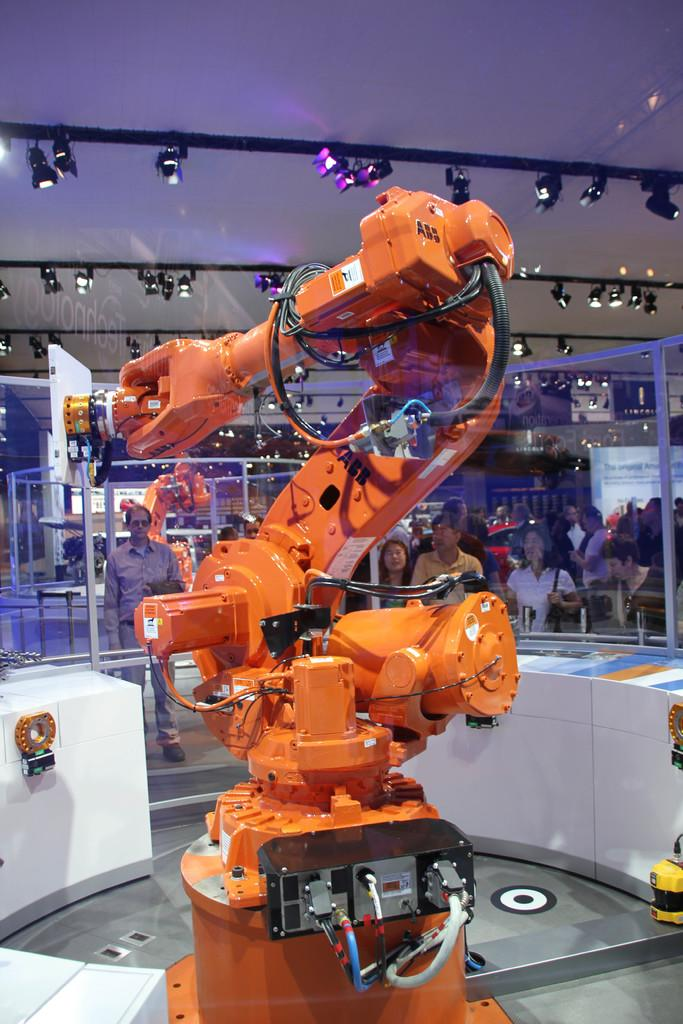What is the main subject of the image? There is a robotic machine in the image. Are there any other subjects in the image besides the robotic machine? Yes, there is a group of people in the image. What objects can be seen in the image that might be used for drinking? There are glasses visible in the image. What can be seen in the image that provides illumination? There are lights in the image. How many spiders are crawling on the robotic machine in the image? There are no spiders present in the image; it only features a robotic machine, a group of people, glasses, and lights. What type of meal is being prepared by the robotic machine in the image? There is no meal being prepared by the robotic machine in the image. 